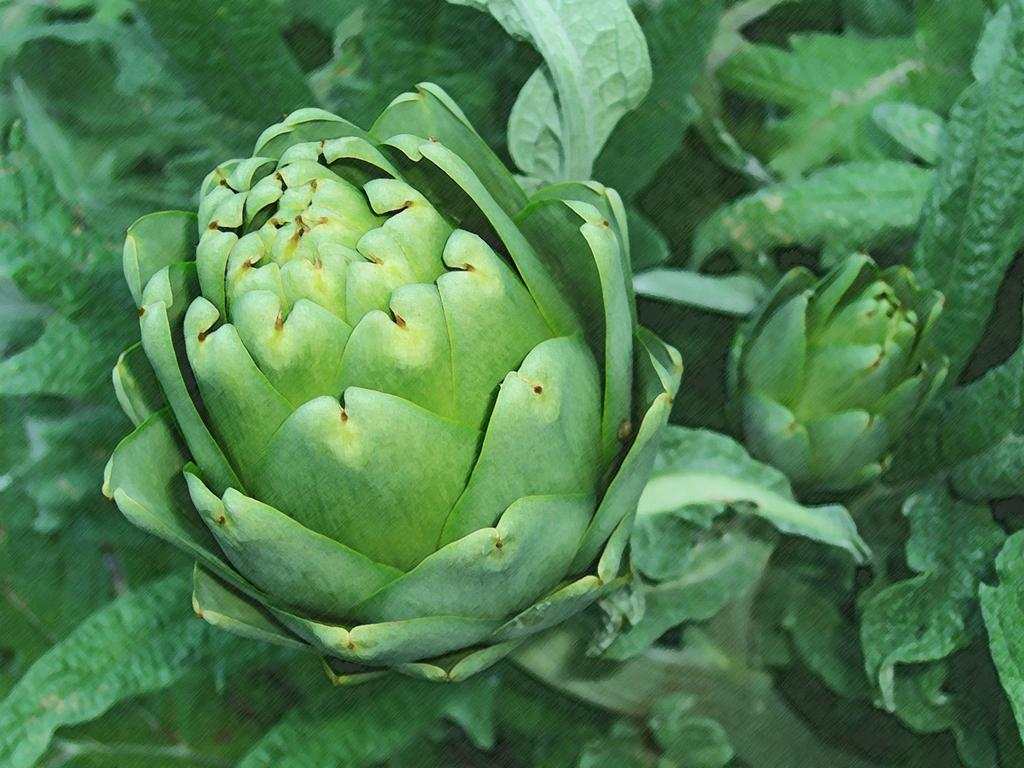What type of living organisms can be seen in the image? Plants can be seen in the image. What type of celery is being used as an armrest in the image? There is no celery or armrest present in the image; it only features plants. 